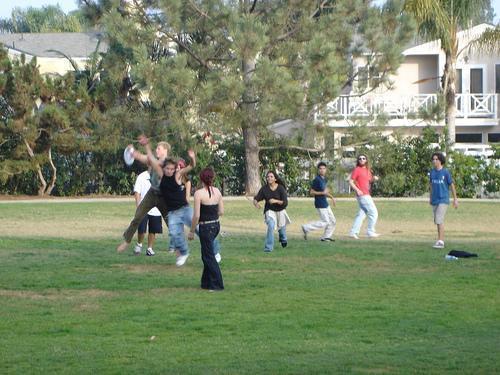How many people are there?
Give a very brief answer. 9. How many people are standing still?
Give a very brief answer. 1. 